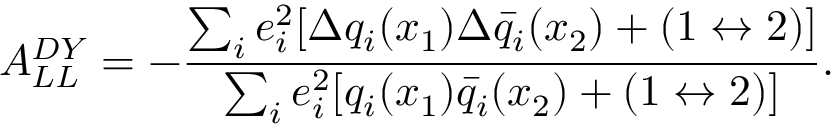Convert formula to latex. <formula><loc_0><loc_0><loc_500><loc_500>A _ { L L } ^ { D Y } = - { \frac { \sum _ { i } e _ { i } ^ { 2 } [ \Delta q _ { i } ( x _ { 1 } ) \Delta \bar { q } _ { i } ( x _ { 2 } ) + ( 1 \leftrightarrow 2 ) ] } { \sum _ { i } e _ { i } ^ { 2 } [ q _ { i } ( x _ { 1 } ) \bar { q } _ { i } ( x _ { 2 } ) + ( 1 \leftrightarrow 2 ) ] } } .</formula> 